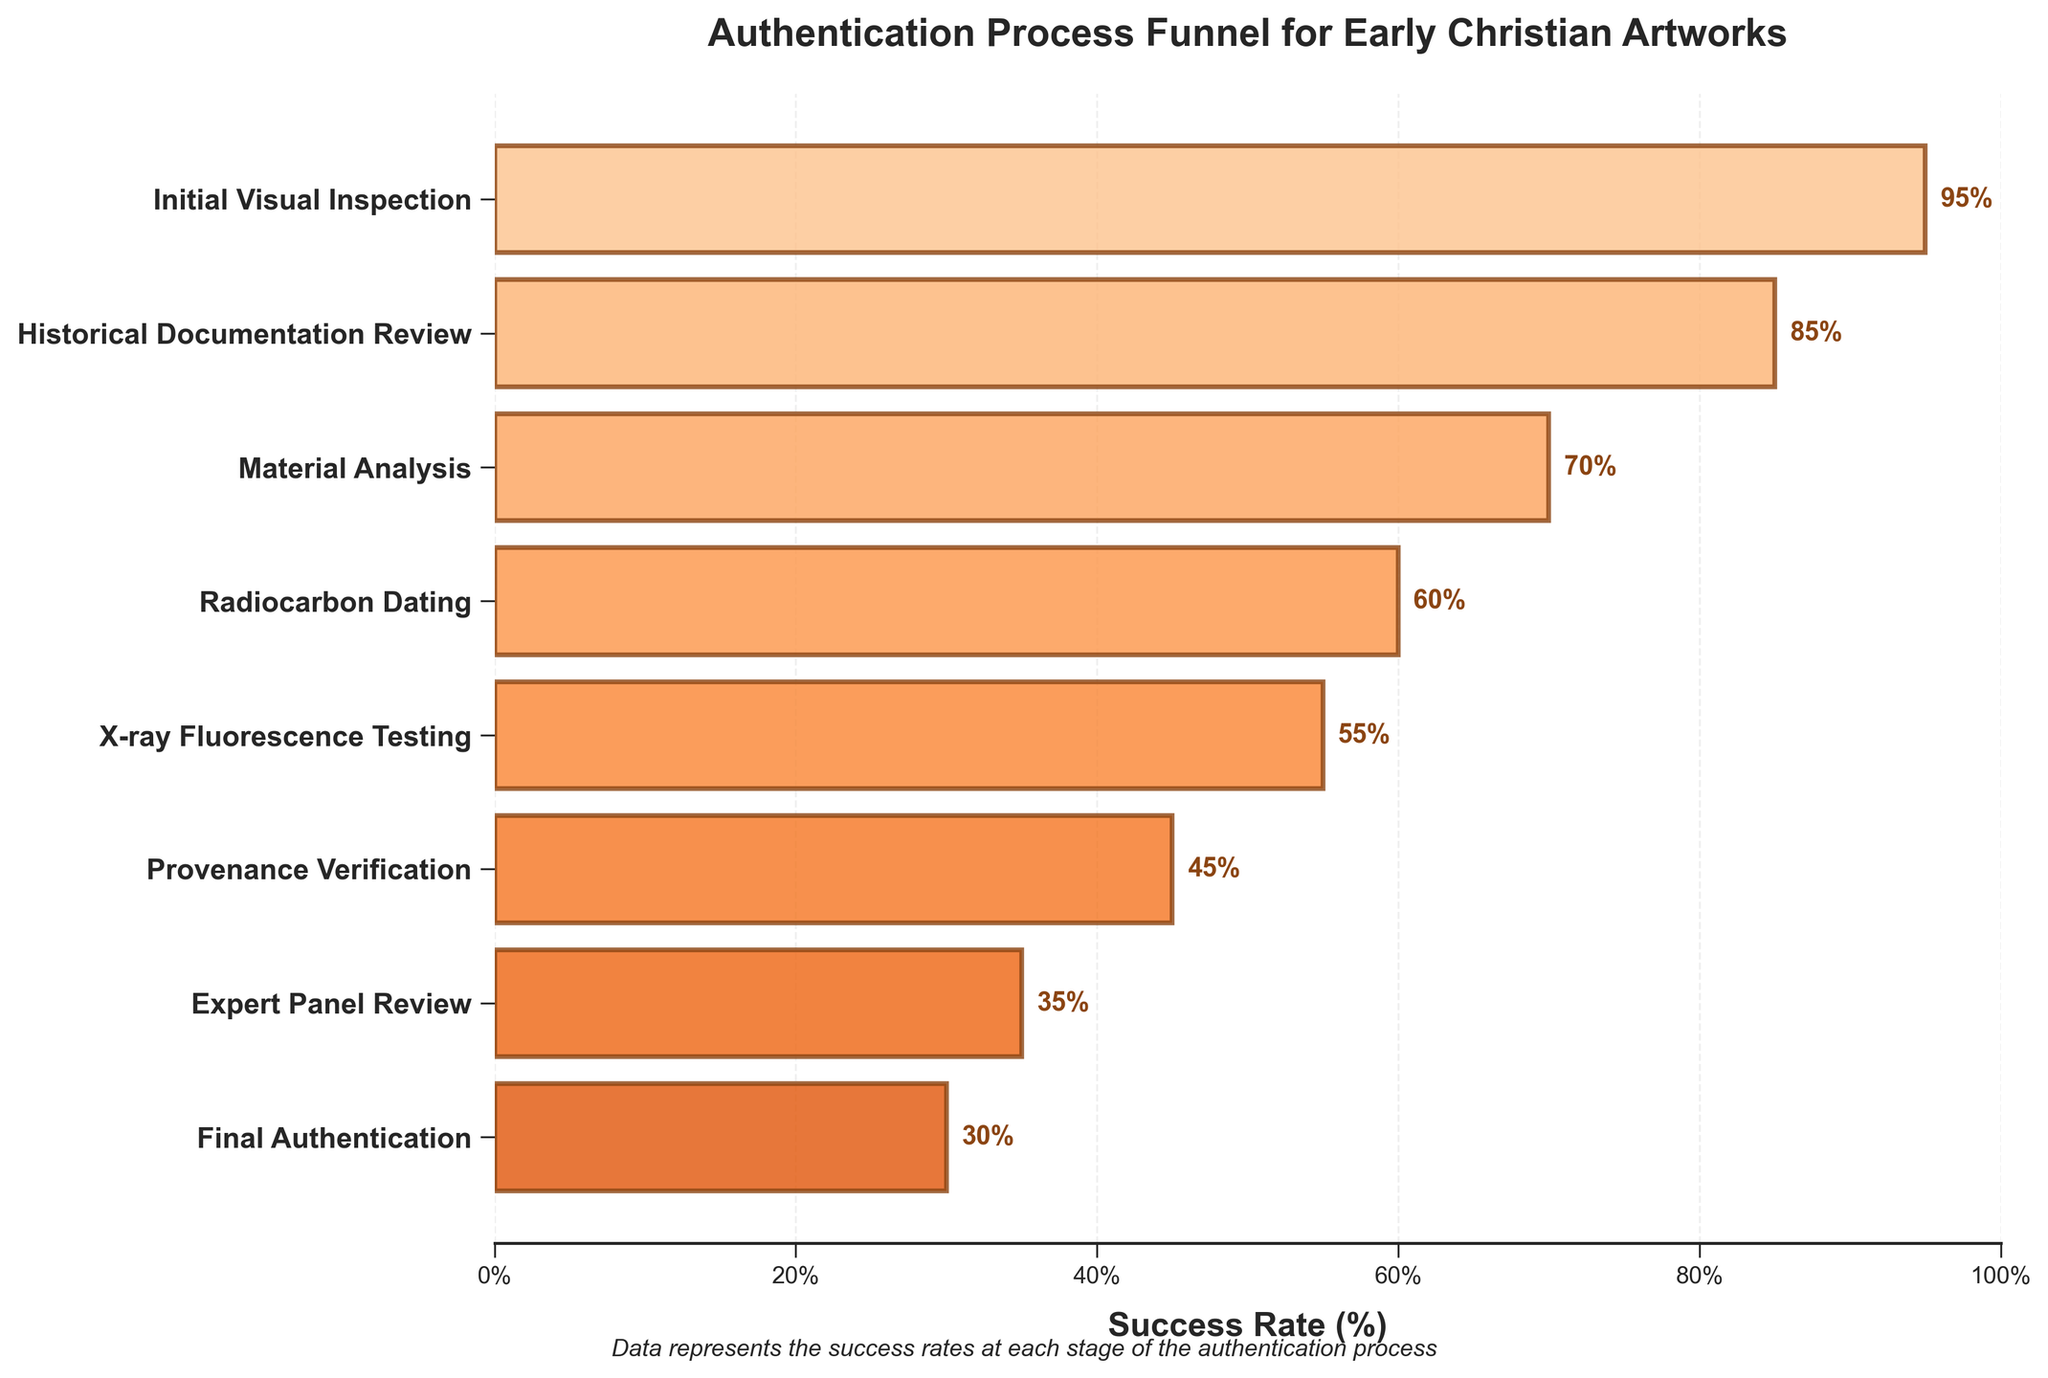What is the overall title of the figure? The title is generally placed at the top of the figure to give an overview of what the data represents. In this case, it states "Authentication Process Funnel for Early Christian Artworks".
Answer: Authentication Process Funnel for Early Christian Artworks Which stage has the highest success rate? Looking at the bar chart, the stage with the longest bar or highest value represents the highest success rate. Here, "Initial Visual Inspection" has the longest bar with the highest success rate.
Answer: Initial Visual Inspection What percentage of artifacts pass the Final Authentication stage? The success rate of each stage is marked by the length of the bar and its label. For the Final Authentication stage, the bar ends at 30%, indicating a 30% success rate.
Answer: 30% Which stage has a success rate of 55%? By identifying the stage where the bar ends at 55% on the x-axis, we find that "X-ray Fluorescence Testing" has a success rate of 55%.
Answer: X-ray Fluorescence Testing What is the difference in success rates between Material Analysis and Provenance Verification? Material Analysis has a success rate of 70%, and Provenance Verification has a success rate of 45%. The difference is calculated by subtracting the smaller percentage from the larger one, 70% - 45% = 25%.
Answer: 25% Which stage immediately precedes Historical Documentation Review in terms of success rate? By following the order of stages from top to bottom in the figure, the stage that comes just before "Historical Documentation Review" is "Initial Visual Inspection".
Answer: Initial Visual Inspection How many stages have a success rate greater than 50%? By examining the success rates of each stage, we count the stages with bars exceeding the 50% mark. These stages are "Initial Visual Inspection", "Historical Documentation Review", "Material Analysis", and "Radiocarbon Dating". This totals to 4 stages.
Answer: 4 What is the average success rate of the first three stages? The success rates of the first three stages (Initial Visual Inspection, Historical Documentation Review, and Material Analysis) are 95%, 85%, and 70% respectively. The average is calculated as (95 + 85 + 70) / 3 = 83.33%.
Answer: 83.33% Which two consecutive stages have the smallest difference in success rates? By checking the success rate differences between consecutive stages, the smallest difference is between "Radiocarbon Dating" (60%) and "X-ray Fluorescence Testing" (55%) with a difference of 5%.
Answer: Radiocarbon Dating and X-ray Fluorescence Testing What is the combined success rate of the last two stages? The success rates of the last two stages (Expert Panel Review and Final Authentication) are 35% and 30% respectively. Adding these gives a combined success rate of 35% + 30% = 65%.
Answer: 65% 